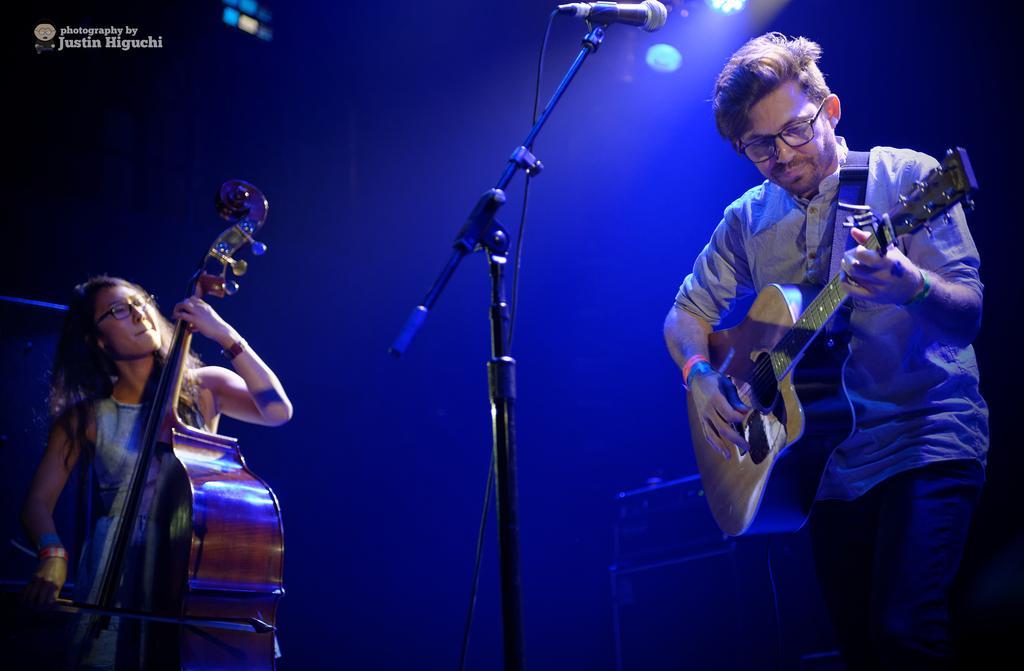Please provide a concise description of this image. In this image I see a man and a woman and both of them are holding the musical instrument. I can also see that there is a mic in front of him. 